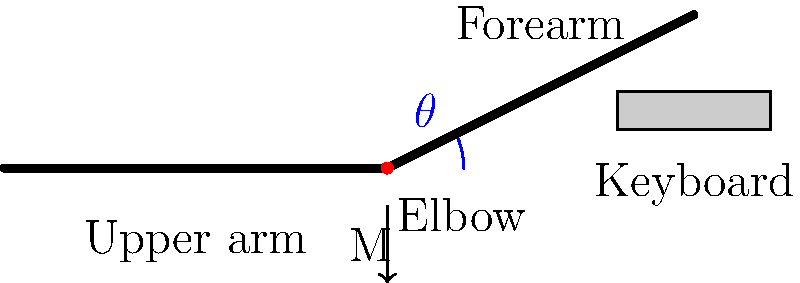As the lead maintainer of the Linux kernel, you're concerned about the ergonomics of long coding sessions. Consider the elbow joint during keyboard typing, as shown in the diagram. If the angle $\theta$ between the upper arm and forearm is 22°, and a moment (M) of 2.5 N·m is generated at the elbow joint, what is the approximate joint reaction force at the elbow, assuming the forearm length is 30 cm and its center of mass is located at its midpoint? To solve this problem, we'll follow these steps:

1. Understand the given information:
   - Elbow angle $\theta = 22°$
   - Moment at elbow $M = 2.5$ N·m
   - Forearm length $L = 30$ cm = 0.3 m
   - Center of mass of forearm is at its midpoint (0.15 m from elbow)

2. The moment at the elbow is caused by the weight of the forearm and hand. We can use this to find the effective weight of the forearm and hand combined:

   $M = F \times d$
   
   Where $F$ is the force (weight) and $d$ is the distance from the elbow to the center of mass.
   
   $2.5 = F \times 0.15$
   $F = 2.5 / 0.15 = 16.67$ N

3. This force acts vertically downward at the center of mass of the forearm. To find the joint reaction force, we need to resolve this force into components parallel and perpendicular to the forearm.

4. The angle between the forearm and the horizontal is $\theta = 22°$. So:
   
   Parallel component: $F_{\parallel} = 16.67 \cos(22°) = 15.47$ N
   Perpendicular component: $F_{\perp} = 16.67 \sin(22°) = 6.24$ N

5. The joint reaction force must balance these components. It will have:
   - A compressive component equal and opposite to $F_{\parallel}$: 15.47 N
   - A shear component equal and opposite to $F_{\perp}$: 6.24 N

6. The total joint reaction force is the vector sum of these components:

   $F_{joint} = \sqrt{15.47^2 + 6.24^2} = 16.67$ N

Therefore, the joint reaction force at the elbow is approximately 16.67 N, which is equal to the weight of the forearm and hand.
Answer: 16.67 N 